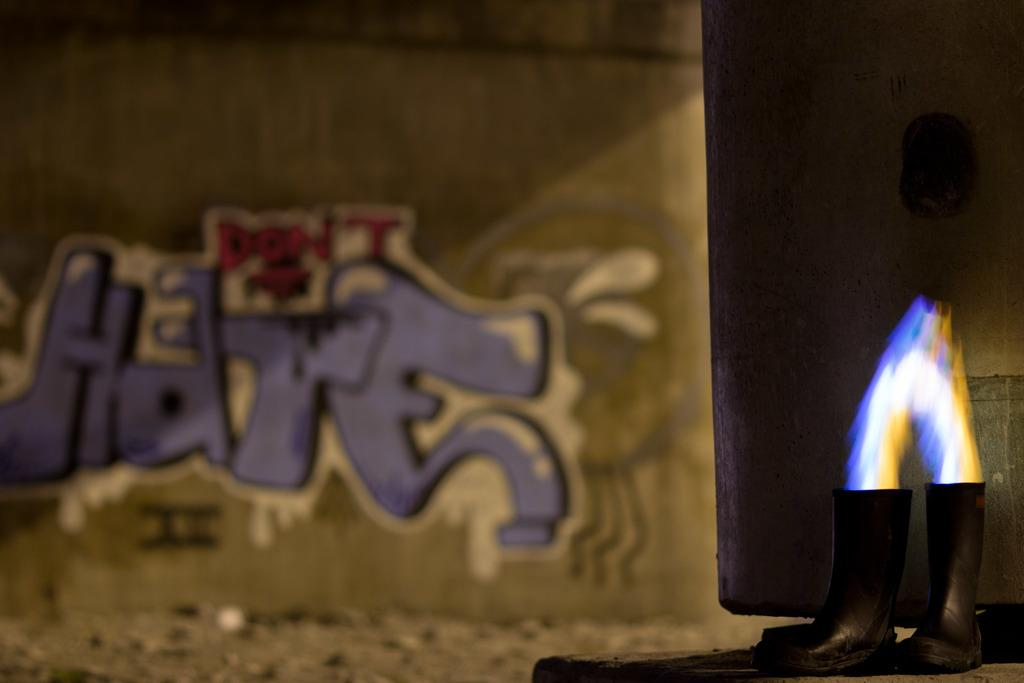What objects are placed on the table in the image? There are shoes on the table in the image. On which side of the table are the shoes located? The shoes are on the right side of the image. What can be seen near a wall in the image? There are flames near a wall in the image. What is depicted on the wall in the background? There is a painting on the wall in the background. How does the father interact with the shoes in the image? There is no father present in the image, and therefore no interaction with the shoes can be observed. 